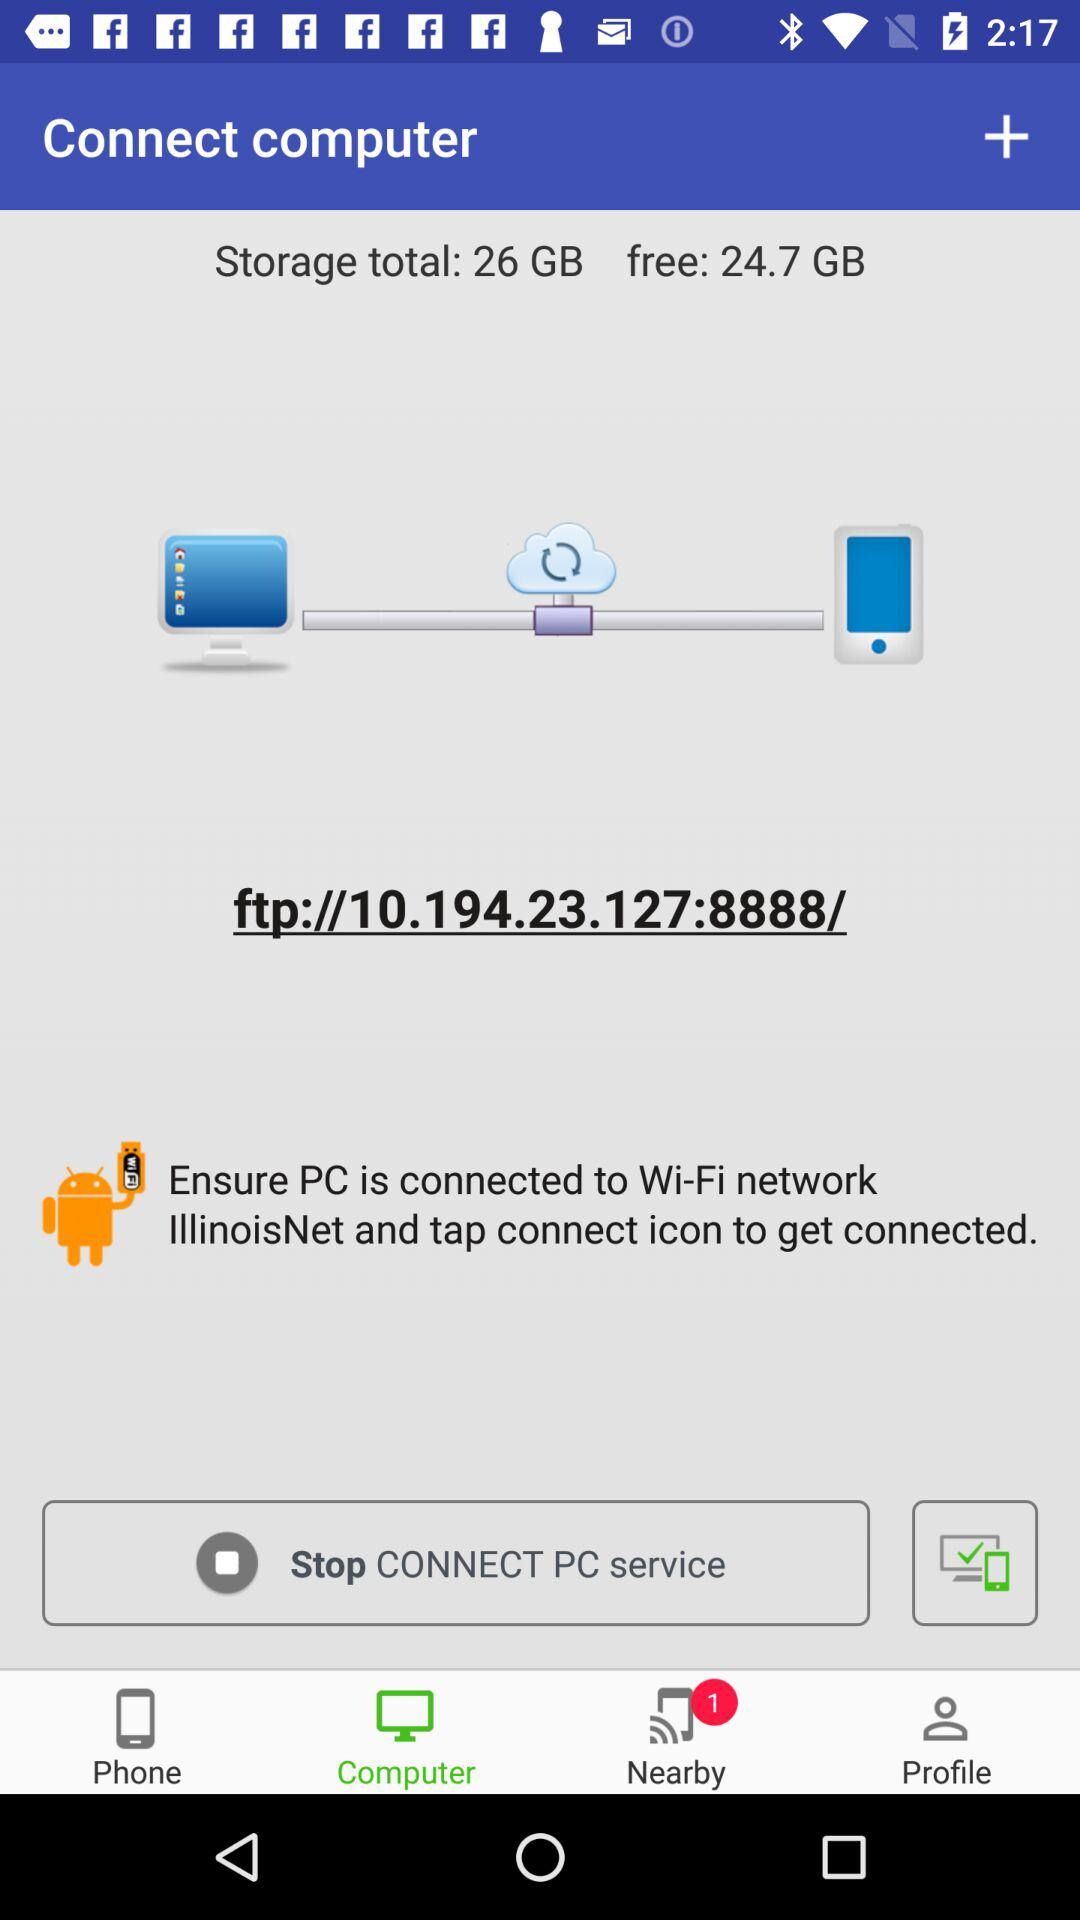How many nearby devices are there? There is 1 nearby device. 